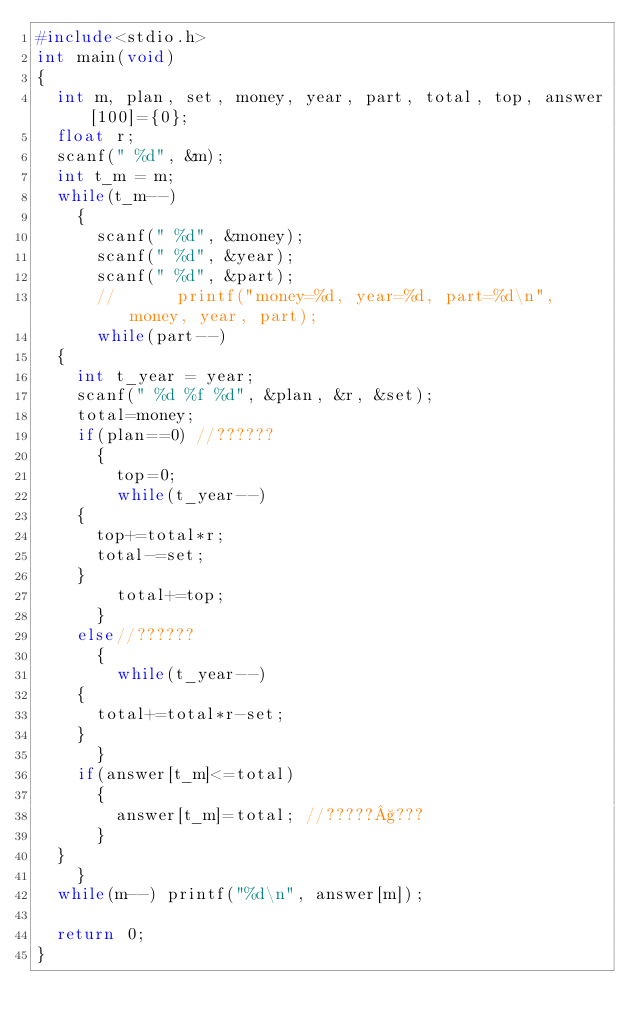<code> <loc_0><loc_0><loc_500><loc_500><_C_>#include<stdio.h>
int main(void)
{
  int m, plan, set, money, year, part, total, top, answer[100]={0}; 
  float r;
  scanf(" %d", &m);
  int t_m = m;
  while(t_m--)
    {
      scanf(" %d", &money);
      scanf(" %d", &year);
      scanf(" %d", &part);
      //      printf("money=%d, year=%d, part=%d\n", money, year, part);
      while(part--)
	{
	  int t_year = year;
	  scanf(" %d %f %d", &plan, &r, &set);
	  total=money;
	  if(plan==0) //??????
	    {
	      top=0;
	      while(t_year--)
		{
		  top+=total*r;
		  total-=set;
		}
	      total+=top;    
	    }
	  else//??????
	    {
	      while(t_year--)
		{
		  total+=total*r-set;	  
		}
	    }
	  if(answer[t_m]<=total)
	    {
	      answer[t_m]=total; //?????§???   
	    }
	}
    }
  while(m--) printf("%d\n", answer[m]);

  return 0;
}</code> 